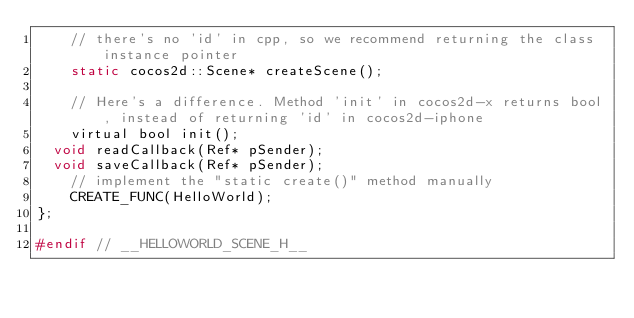Convert code to text. <code><loc_0><loc_0><loc_500><loc_500><_C_>    // there's no 'id' in cpp, so we recommend returning the class instance pointer
    static cocos2d::Scene* createScene();

    // Here's a difference. Method 'init' in cocos2d-x returns bool, instead of returning 'id' in cocos2d-iphone
    virtual bool init();
	void readCallback(Ref* pSender);
	void saveCallback(Ref* pSender);
    // implement the "static create()" method manually
    CREATE_FUNC(HelloWorld);
};

#endif // __HELLOWORLD_SCENE_H__
</code> 